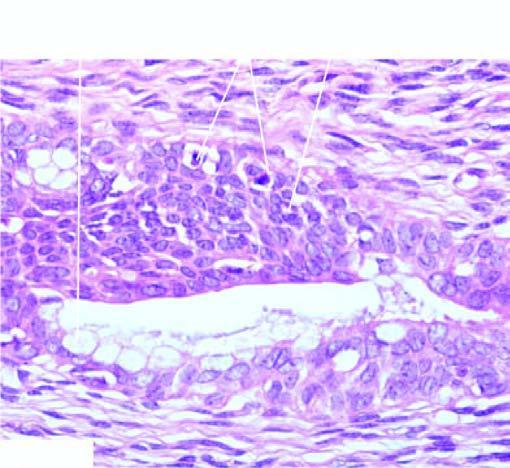what have layers of squamous epithelium marked?
Answer the question using a single word or phrase. Cytologic atypia 